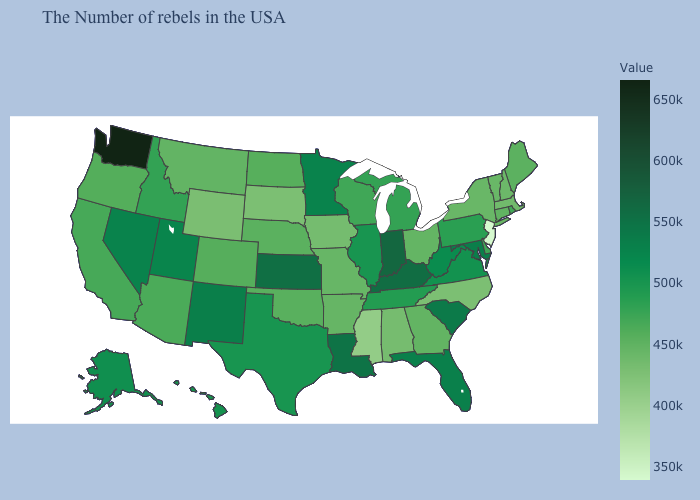Does South Carolina have a lower value than Washington?
Concise answer only. Yes. Is the legend a continuous bar?
Answer briefly. Yes. Does California have the lowest value in the USA?
Answer briefly. No. Among the states that border Wyoming , does South Dakota have the highest value?
Write a very short answer. No. Does Mississippi have a higher value than Indiana?
Short answer required. No. Does Maine have a higher value than Tennessee?
Short answer required. No. Among the states that border Colorado , which have the highest value?
Quick response, please. Kansas. 